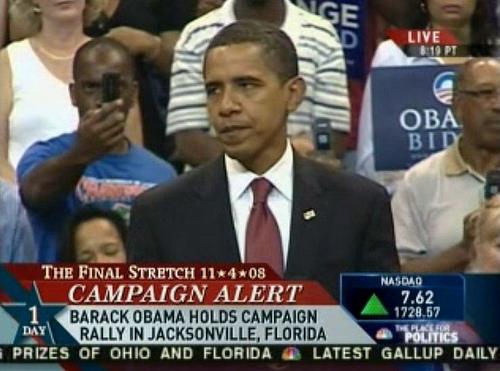What is the caption of the photo?
Concise answer only. Campaign alert. Who is the man in the middle?
Quick response, please. Obama. What network is this broadcast on?
Answer briefly. Nbc. 